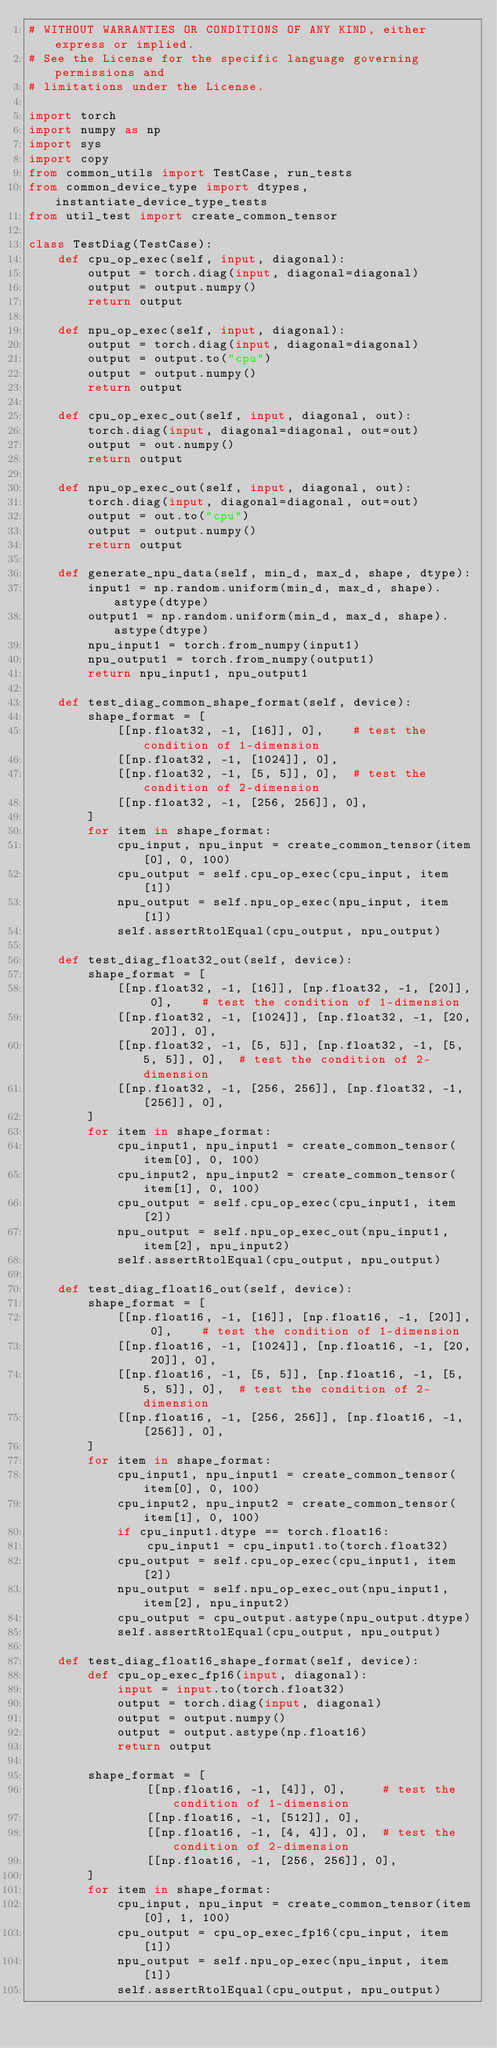<code> <loc_0><loc_0><loc_500><loc_500><_Python_># WITHOUT WARRANTIES OR CONDITIONS OF ANY KIND, either express or implied.
# See the License for the specific language governing permissions and
# limitations under the License.

import torch
import numpy as np
import sys
import copy
from common_utils import TestCase, run_tests
from common_device_type import dtypes, instantiate_device_type_tests
from util_test import create_common_tensor

class TestDiag(TestCase):
    def cpu_op_exec(self, input, diagonal):
        output = torch.diag(input, diagonal=diagonal)
        output = output.numpy()
        return output

    def npu_op_exec(self, input, diagonal):
        output = torch.diag(input, diagonal=diagonal)
        output = output.to("cpu")
        output = output.numpy()
        return output

    def cpu_op_exec_out(self, input, diagonal, out):
        torch.diag(input, diagonal=diagonal, out=out)
        output = out.numpy()
        return output

    def npu_op_exec_out(self, input, diagonal, out):
        torch.diag(input, diagonal=diagonal, out=out)
        output = out.to("cpu")
        output = output.numpy()
        return output

    def generate_npu_data(self, min_d, max_d, shape, dtype):
        input1 = np.random.uniform(min_d, max_d, shape).astype(dtype)
        output1 = np.random.uniform(min_d, max_d, shape).astype(dtype)
        npu_input1 = torch.from_numpy(input1)
        npu_output1 = torch.from_numpy(output1)
        return npu_input1, npu_output1

    def test_diag_common_shape_format(self, device):
        shape_format = [
            [[np.float32, -1, [16]], 0],    # test the condition of 1-dimension
            [[np.float32, -1, [1024]], 0],    
            [[np.float32, -1, [5, 5]], 0],  # test the condition of 2-dimension
            [[np.float32, -1, [256, 256]], 0],
        ]
        for item in shape_format:
            cpu_input, npu_input = create_common_tensor(item[0], 0, 100)
            cpu_output = self.cpu_op_exec(cpu_input, item[1])
            npu_output = self.npu_op_exec(npu_input, item[1])
            self.assertRtolEqual(cpu_output, npu_output)
    
    def test_diag_float32_out(self, device):
        shape_format = [
            [[np.float32, -1, [16]], [np.float32, -1, [20]], 0],    # test the condition of 1-dimension
            [[np.float32, -1, [1024]], [np.float32, -1, [20, 20]], 0],    
            [[np.float32, -1, [5, 5]], [np.float32, -1, [5, 5, 5]], 0],  # test the condition of 2-dimension
            [[np.float32, -1, [256, 256]], [np.float32, -1, [256]], 0],
        ]
        for item in shape_format:
            cpu_input1, npu_input1 = create_common_tensor(item[0], 0, 100)
            cpu_input2, npu_input2 = create_common_tensor(item[1], 0, 100)
            cpu_output = self.cpu_op_exec(cpu_input1, item[2])
            npu_output = self.npu_op_exec_out(npu_input1, item[2], npu_input2)
            self.assertRtolEqual(cpu_output, npu_output)

    def test_diag_float16_out(self, device):
        shape_format = [
            [[np.float16, -1, [16]], [np.float16, -1, [20]], 0],    # test the condition of 1-dimension
            [[np.float16, -1, [1024]], [np.float16, -1, [20, 20]], 0],    
            [[np.float16, -1, [5, 5]], [np.float16, -1, [5, 5, 5]], 0],  # test the condition of 2-dimension
            [[np.float16, -1, [256, 256]], [np.float16, -1, [256]], 0],
        ]
        for item in shape_format:
            cpu_input1, npu_input1 = create_common_tensor(item[0], 0, 100)
            cpu_input2, npu_input2 = create_common_tensor(item[1], 0, 100)
            if cpu_input1.dtype == torch.float16:
                cpu_input1 = cpu_input1.to(torch.float32)
            cpu_output = self.cpu_op_exec(cpu_input1, item[2])
            npu_output = self.npu_op_exec_out(npu_input1, item[2], npu_input2)
            cpu_output = cpu_output.astype(npu_output.dtype)
            self.assertRtolEqual(cpu_output, npu_output)

    def test_diag_float16_shape_format(self, device):
        def cpu_op_exec_fp16(input, diagonal):
            input = input.to(torch.float32)
            output = torch.diag(input, diagonal)
            output = output.numpy()
            output = output.astype(np.float16)
            return output

        shape_format = [
                [[np.float16, -1, [4]], 0],     # test the condition of 1-dimension
                [[np.float16, -1, [512]], 0],
                [[np.float16, -1, [4, 4]], 0],  # test the condition of 2-dimension
                [[np.float16, -1, [256, 256]], 0],
        ] 
        for item in shape_format:
            cpu_input, npu_input = create_common_tensor(item[0], 1, 100)
            cpu_output = cpu_op_exec_fp16(cpu_input, item[1])
            npu_output = self.npu_op_exec(npu_input, item[1])
            self.assertRtolEqual(cpu_output, npu_output)  
</code> 